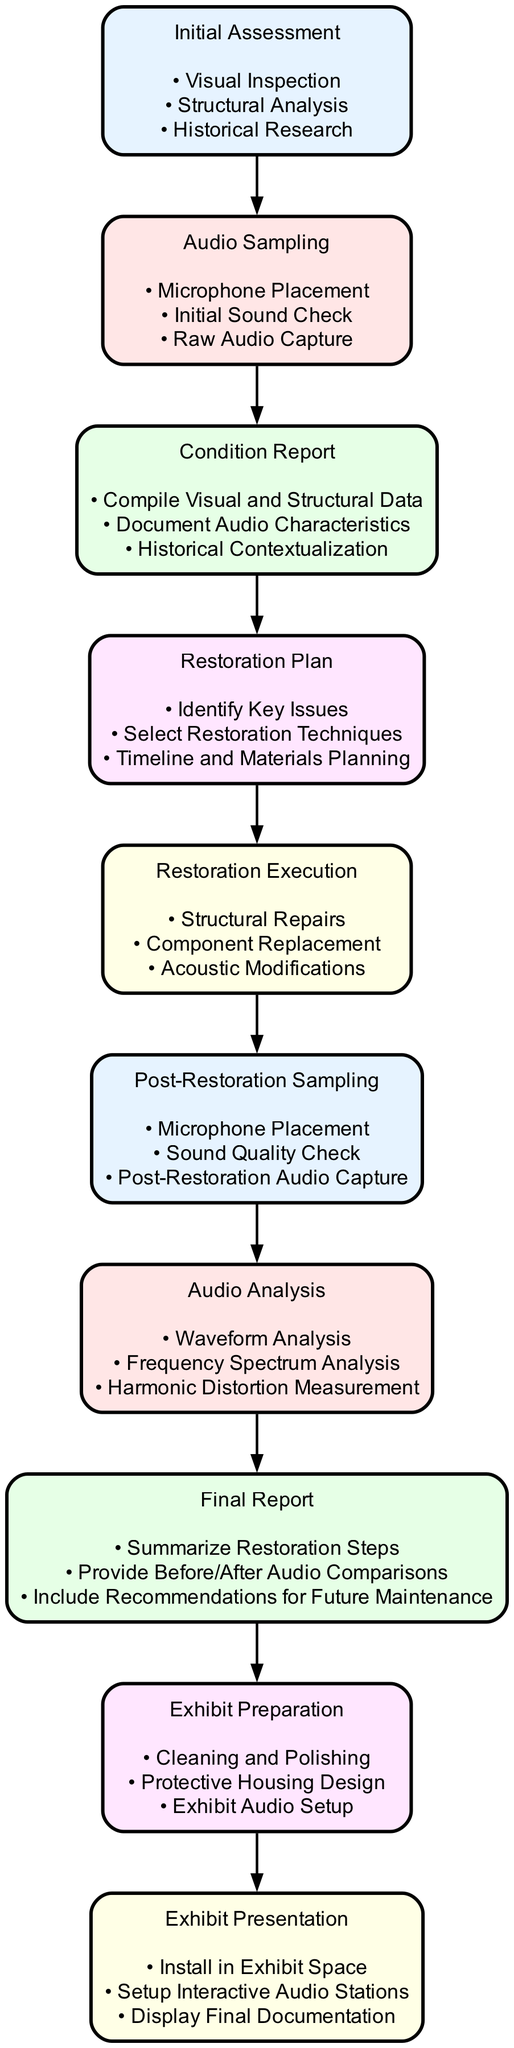What is the first step in the audio restoration workflow? The diagram indicates that "Initial Assessment" is the first step in the audio restoration workflow.
Answer: Initial Assessment How many tasks are involved in the "Restoration Execution" phase? The "Restoration Execution" phase includes three tasks: Structural Repairs, Component Replacement, and Acoustic Modifications as shown in the diagram.
Answer: 3 What follows the "Audio Analysis" step in the workflow? According to the diagram, the step that directly follows "Audio Analysis" is "Final Report."
Answer: Final Report Which two phases involve audio recording and examination? The diagram shows that "Audio Sampling" and "Post-Restoration Sampling" are the two phases that involve audio recording and analysis, reflecting on the progress of the restoration.
Answer: Audio Sampling, Post-Restoration Sampling What is documented in the "Final Report"? The "Final Report" documents the restoration steps taken, including before and after comparisons, as depicted in the diagram tasks.
Answer: Restoration Steps, Before/After Comparisons How many main elements are there in the entire workflow? The diagram lists nine main elements in the audio restoration workflow, which include Initial Assessment, Audio Sampling, and so on.
Answer: 9 Which phase includes "Historical Contextualization"? The "Condition Report" phase of the workflow includes the task "Historical Contextualization," as shown in the diagram.
Answer: Condition Report What is included in the "Exhibit Preparation" phase? The "Exhibit Preparation" phase includes tasks such as Cleaning and Polishing, Protective Housing Design, and Exhibit Audio Setup as listed in the diagram.
Answer: Cleaning and Polishing, Protective Housing Design, Exhibit Audio Setup What type of analysis is performed in the "Audio Analysis" step? The "Audio Analysis" step performs Waveform Analysis, Frequency Spectrum Analysis, and Harmonic Distortion Measurement as per the tasks mentioned in the diagram.
Answer: Waveform Analysis, Frequency Spectrum Analysis, Harmonic Distortion Measurement 